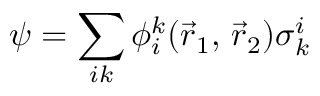Convert formula to latex. <formula><loc_0><loc_0><loc_500><loc_500>{ \psi } = \sum _ { i k } \phi _ { i } ^ { k } ( { \vec { r } } _ { 1 } , \, { \vec { r } } _ { 2 } ) { \sigma } _ { k } ^ { i }</formula> 